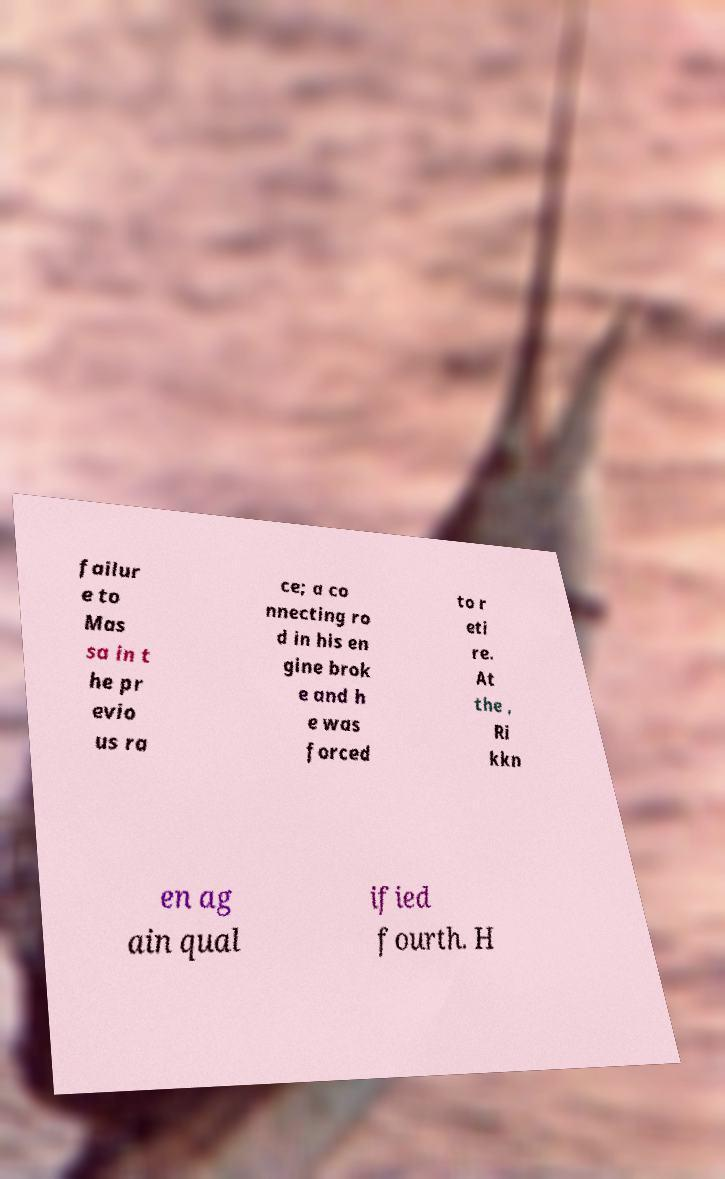Please identify and transcribe the text found in this image. failur e to Mas sa in t he pr evio us ra ce; a co nnecting ro d in his en gine brok e and h e was forced to r eti re. At the , Ri kkn en ag ain qual ified fourth. H 